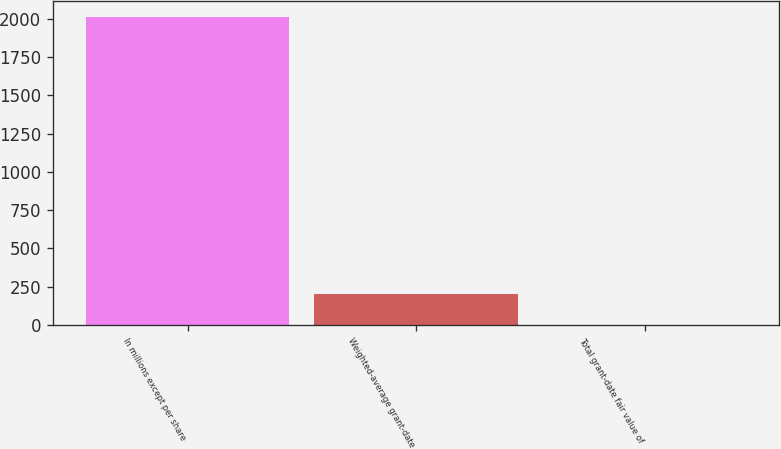Convert chart to OTSL. <chart><loc_0><loc_0><loc_500><loc_500><bar_chart><fcel>In millions except per share<fcel>Weighted-average grant-date<fcel>Total grant-date fair value of<nl><fcel>2012<fcel>204.08<fcel>3.2<nl></chart> 